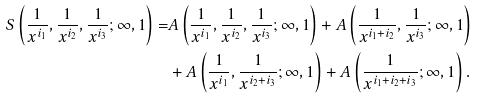Convert formula to latex. <formula><loc_0><loc_0><loc_500><loc_500>S \left ( \frac { 1 } { x ^ { i _ { 1 } } } , \frac { 1 } { x ^ { i _ { 2 } } } , \frac { 1 } { x ^ { i _ { 3 } } } ; \infty , 1 \right ) = & A \left ( \frac { 1 } { x ^ { i _ { 1 } } } , \frac { 1 } { x ^ { i _ { 2 } } } , \frac { 1 } { x ^ { i _ { 3 } } } ; \infty , 1 \right ) + A \left ( \frac { 1 } { x ^ { i _ { 1 } + i _ { 2 } } } , \frac { 1 } { x ^ { i _ { 3 } } } ; \infty , 1 \right ) \\ & + A \left ( \frac { 1 } { x ^ { i _ { 1 } } } , \frac { 1 } { x ^ { i _ { 2 } + i _ { 3 } } } ; \infty , 1 \right ) + A \left ( \frac { 1 } { x ^ { i _ { 1 } + i _ { 2 } + i _ { 3 } } } ; \infty , 1 \right ) .</formula> 